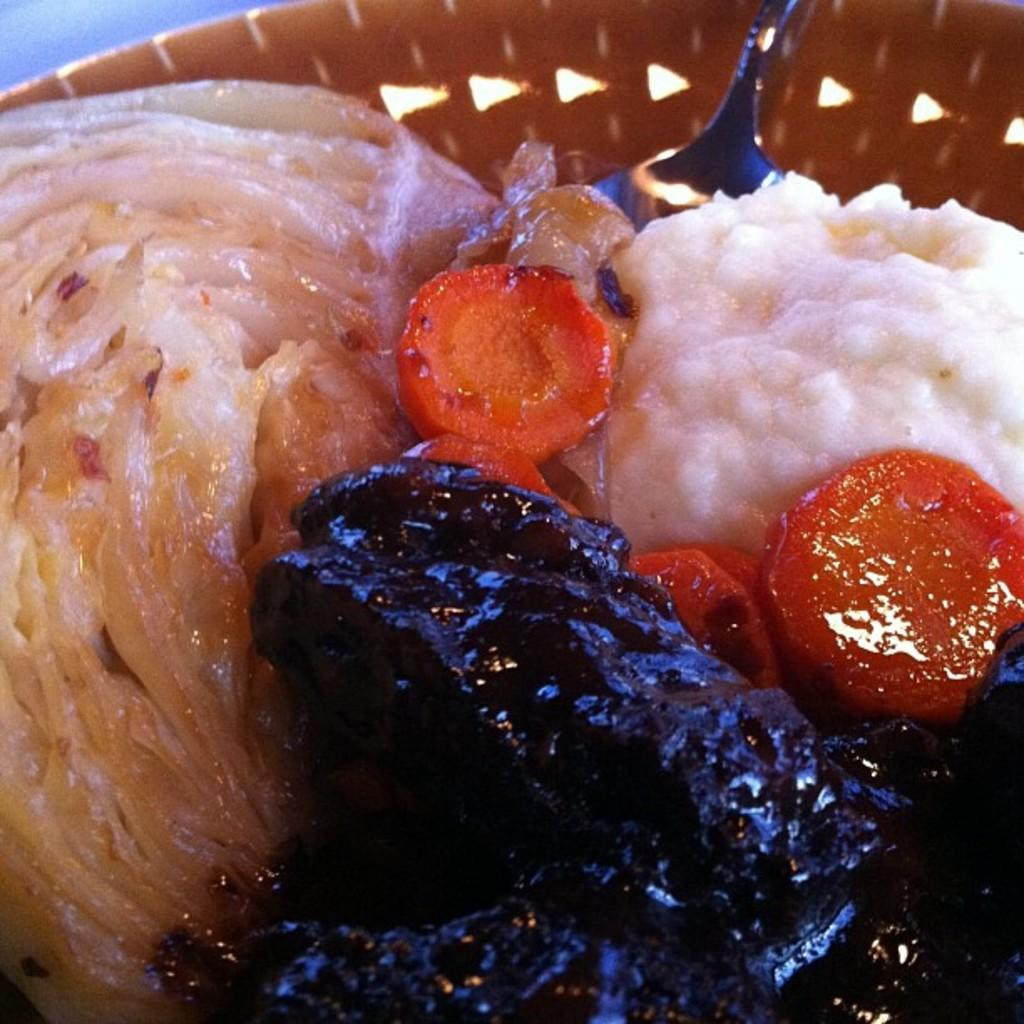What type of items can be seen in the image? There are food items in the image. Can you describe the utensil that is present in the image? There is a spoon in a bowl in the image. What is the name of the person who is operating the trains in the image? There are no trains or people operating trains present in the image. Is there a net visible in the image? There is no net present in the image. 